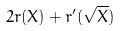Convert formula to latex. <formula><loc_0><loc_0><loc_500><loc_500>2 r ( X ) + r ^ { \prime } ( \sqrt { X } )</formula> 